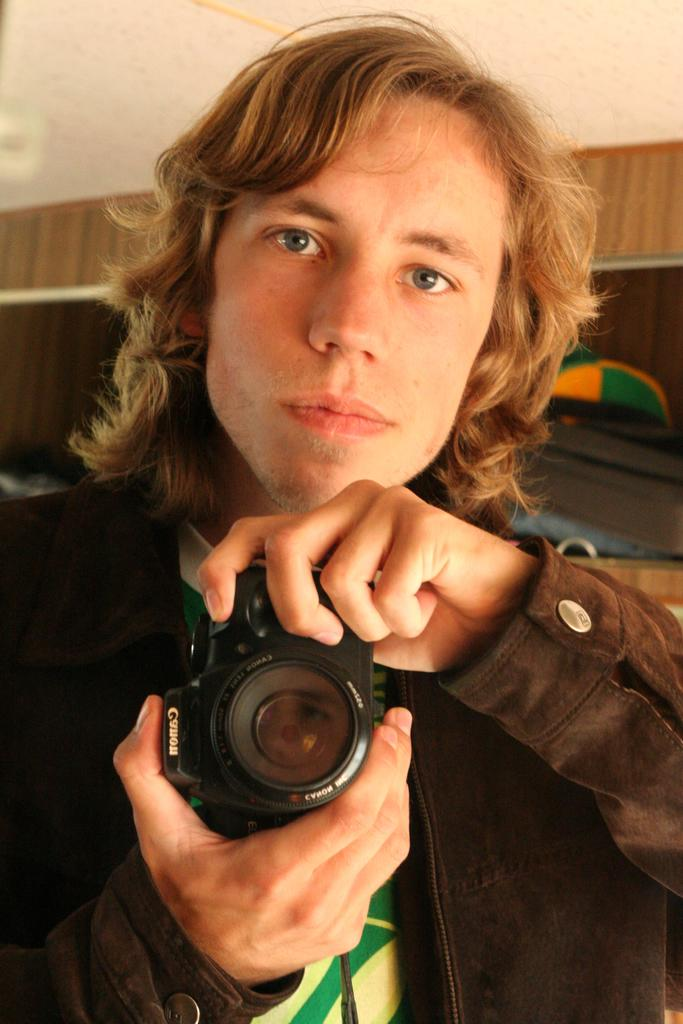What is the man in the image holding? The man is holding a camera. What is the man wearing in the image? The man is wearing a black jacket. Where was the image taken? The image was taken in a room. What can be seen in the background of the image? There is a wall and a rack in the background of the image. What news is the man reading from the umbrella in the image? There is no umbrella or news present in the image. The man is holding a camera and is not reading anything. 